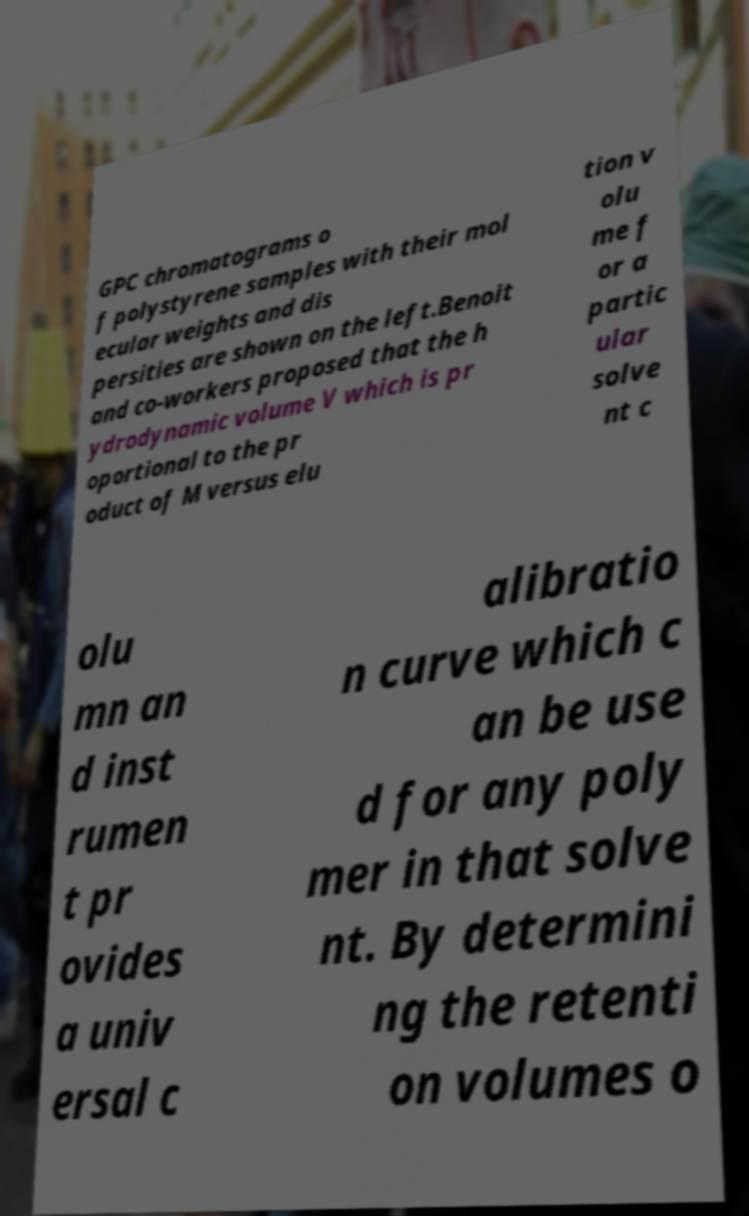What messages or text are displayed in this image? I need them in a readable, typed format. GPC chromatograms o f polystyrene samples with their mol ecular weights and dis persities are shown on the left.Benoit and co-workers proposed that the h ydrodynamic volume V which is pr oportional to the pr oduct of M versus elu tion v olu me f or a partic ular solve nt c olu mn an d inst rumen t pr ovides a univ ersal c alibratio n curve which c an be use d for any poly mer in that solve nt. By determini ng the retenti on volumes o 